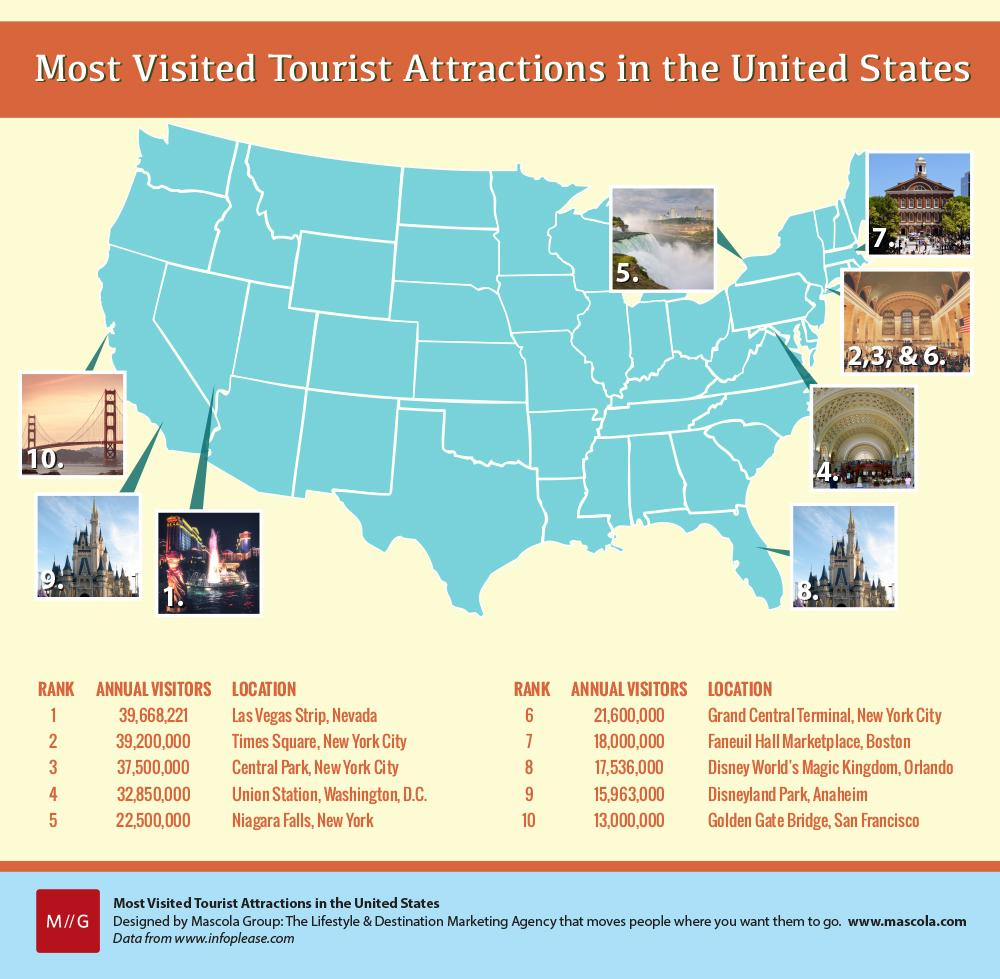Draw attention to some important aspects in this diagram. The color of the map of the US is blue. Faneuil Hall Marketplace is the seventh most visited tourist attraction in the United States. The Las Vegas Strip in Nevada receives more visitors than Times Square, a popular attraction in New York City. 